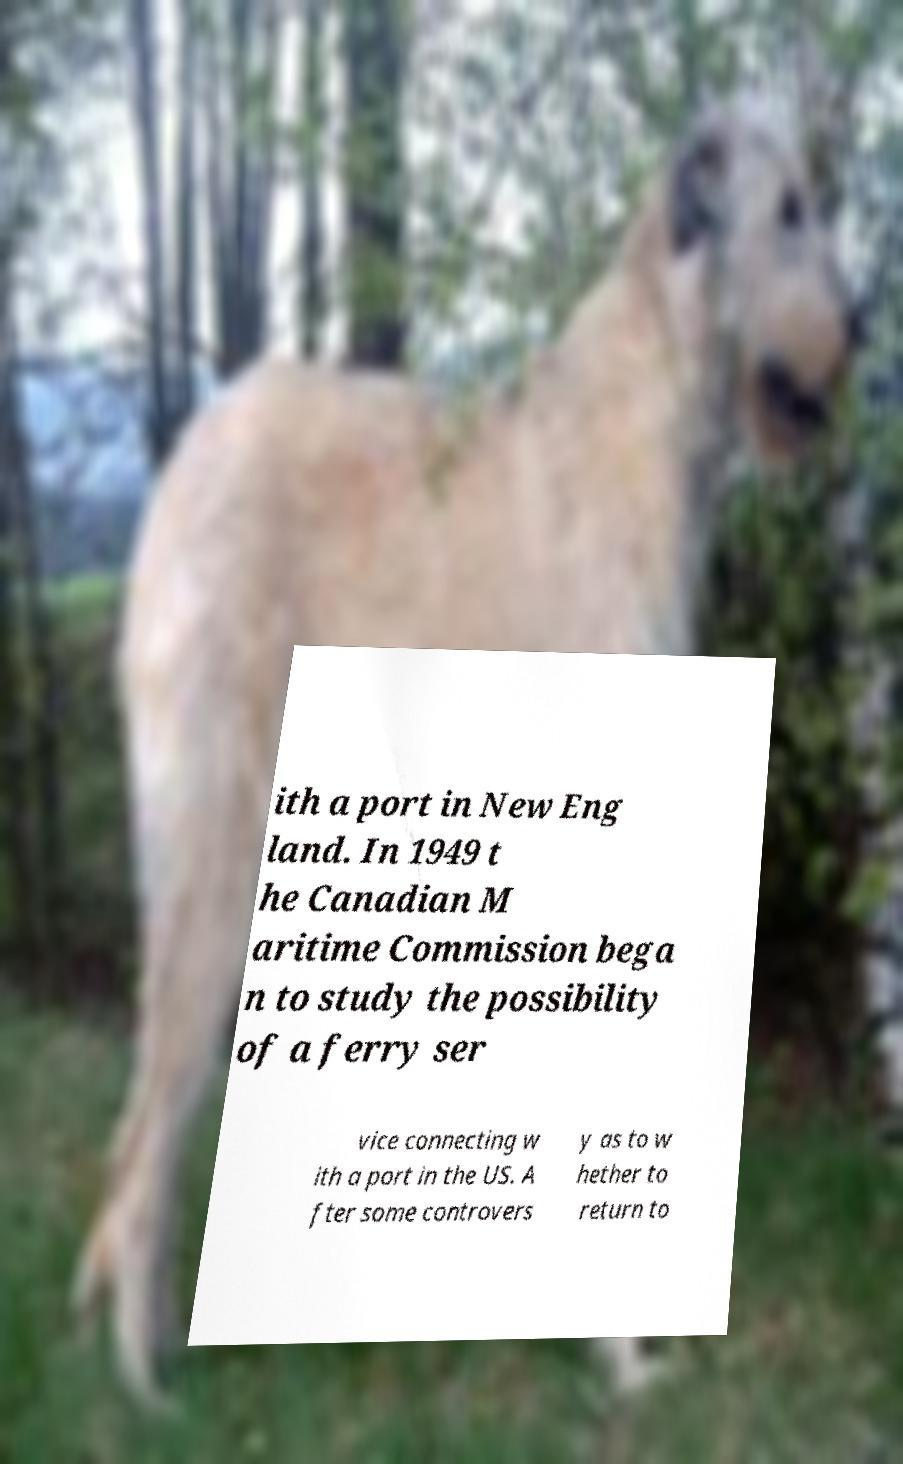Can you accurately transcribe the text from the provided image for me? ith a port in New Eng land. In 1949 t he Canadian M aritime Commission bega n to study the possibility of a ferry ser vice connecting w ith a port in the US. A fter some controvers y as to w hether to return to 